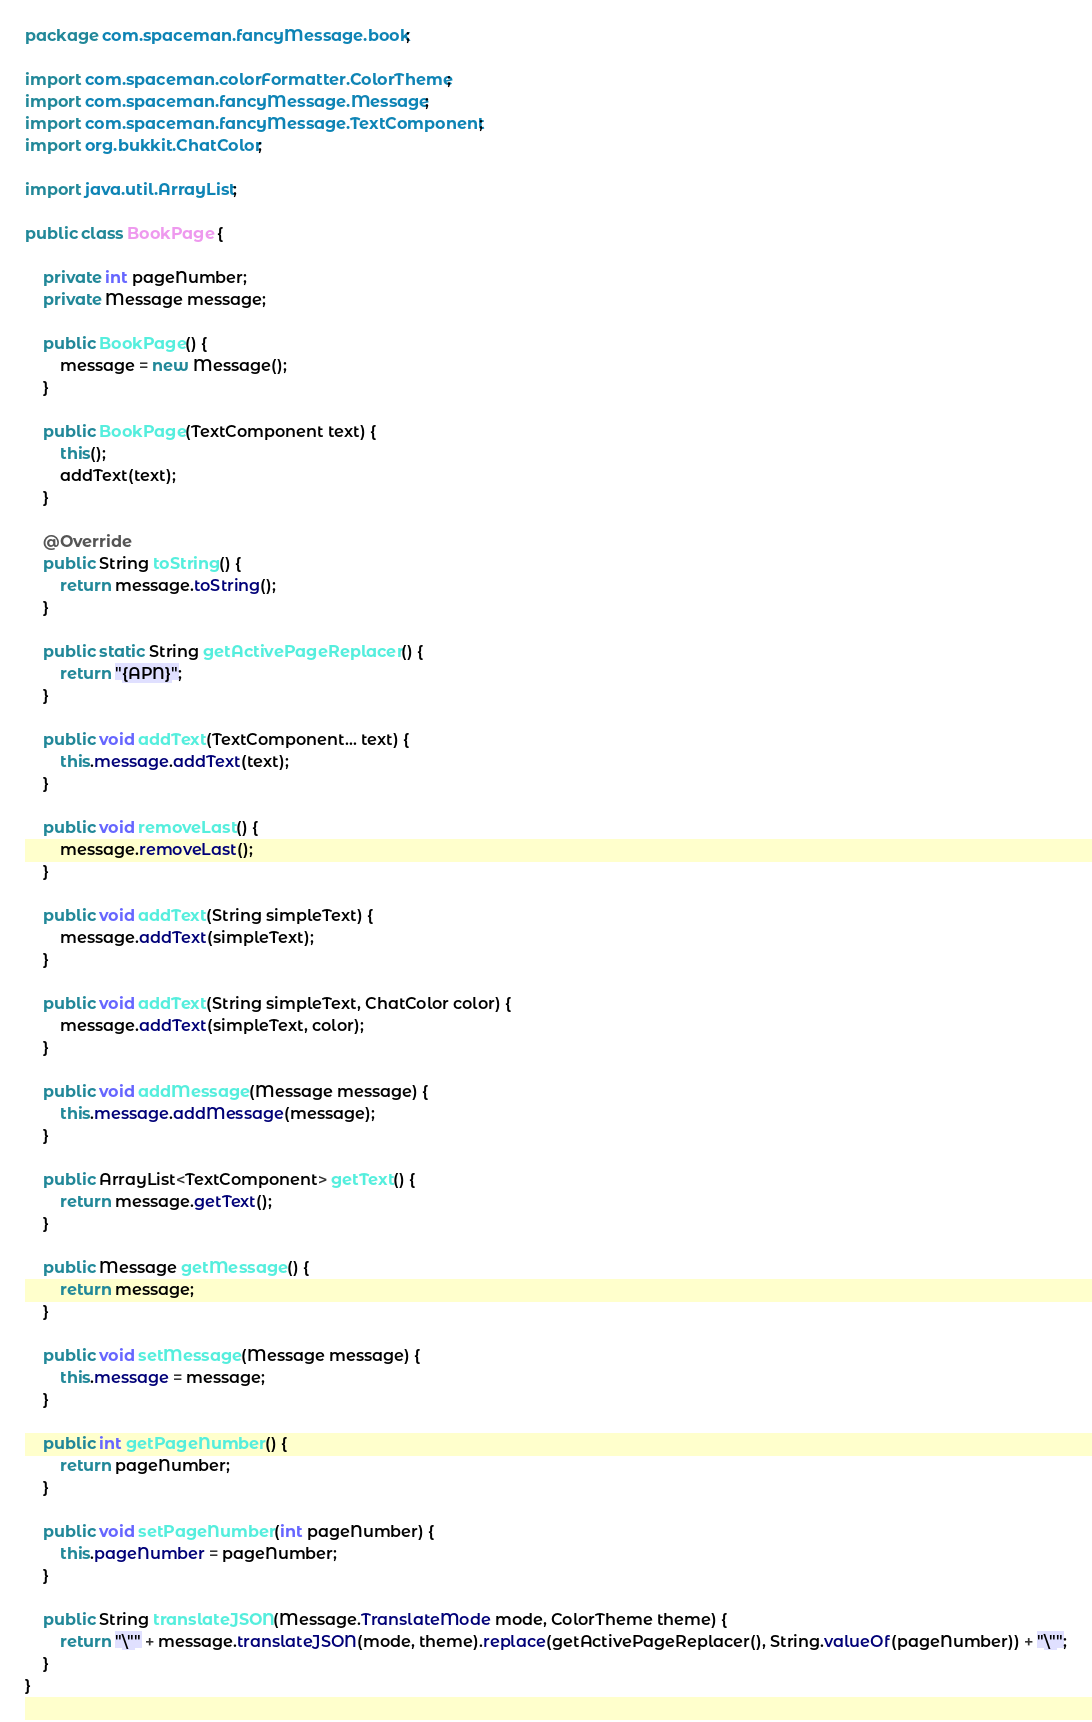<code> <loc_0><loc_0><loc_500><loc_500><_Java_>package com.spaceman.fancyMessage.book;

import com.spaceman.colorFormatter.ColorTheme;
import com.spaceman.fancyMessage.Message;
import com.spaceman.fancyMessage.TextComponent;
import org.bukkit.ChatColor;

import java.util.ArrayList;

public class BookPage {
    
    private int pageNumber;
    private Message message;
    
    public BookPage() {
        message = new Message();
    }
    
    public BookPage(TextComponent text) {
        this();
        addText(text);
    }
    
    @Override
    public String toString() {
        return message.toString();
    }
    
    public static String getActivePageReplacer() {
        return "{APN}";
    }
    
    public void addText(TextComponent... text) {
        this.message.addText(text);
    }
    
    public void removeLast() {
        message.removeLast();
    }
    
    public void addText(String simpleText) {
        message.addText(simpleText);
    }
    
    public void addText(String simpleText, ChatColor color) {
        message.addText(simpleText, color);
    }
    
    public void addMessage(Message message) {
        this.message.addMessage(message);
    }
    
    public ArrayList<TextComponent> getText() {
        return message.getText();
    }
    
    public Message getMessage() {
        return message;
    }
    
    public void setMessage(Message message) {
        this.message = message;
    }
    
    public int getPageNumber() {
        return pageNumber;
    }
    
    public void setPageNumber(int pageNumber) {
        this.pageNumber = pageNumber;
    }
    
    public String translateJSON(Message.TranslateMode mode, ColorTheme theme) {
        return "\"" + message.translateJSON(mode, theme).replace(getActivePageReplacer(), String.valueOf(pageNumber)) + "\"";
    }
}
</code> 